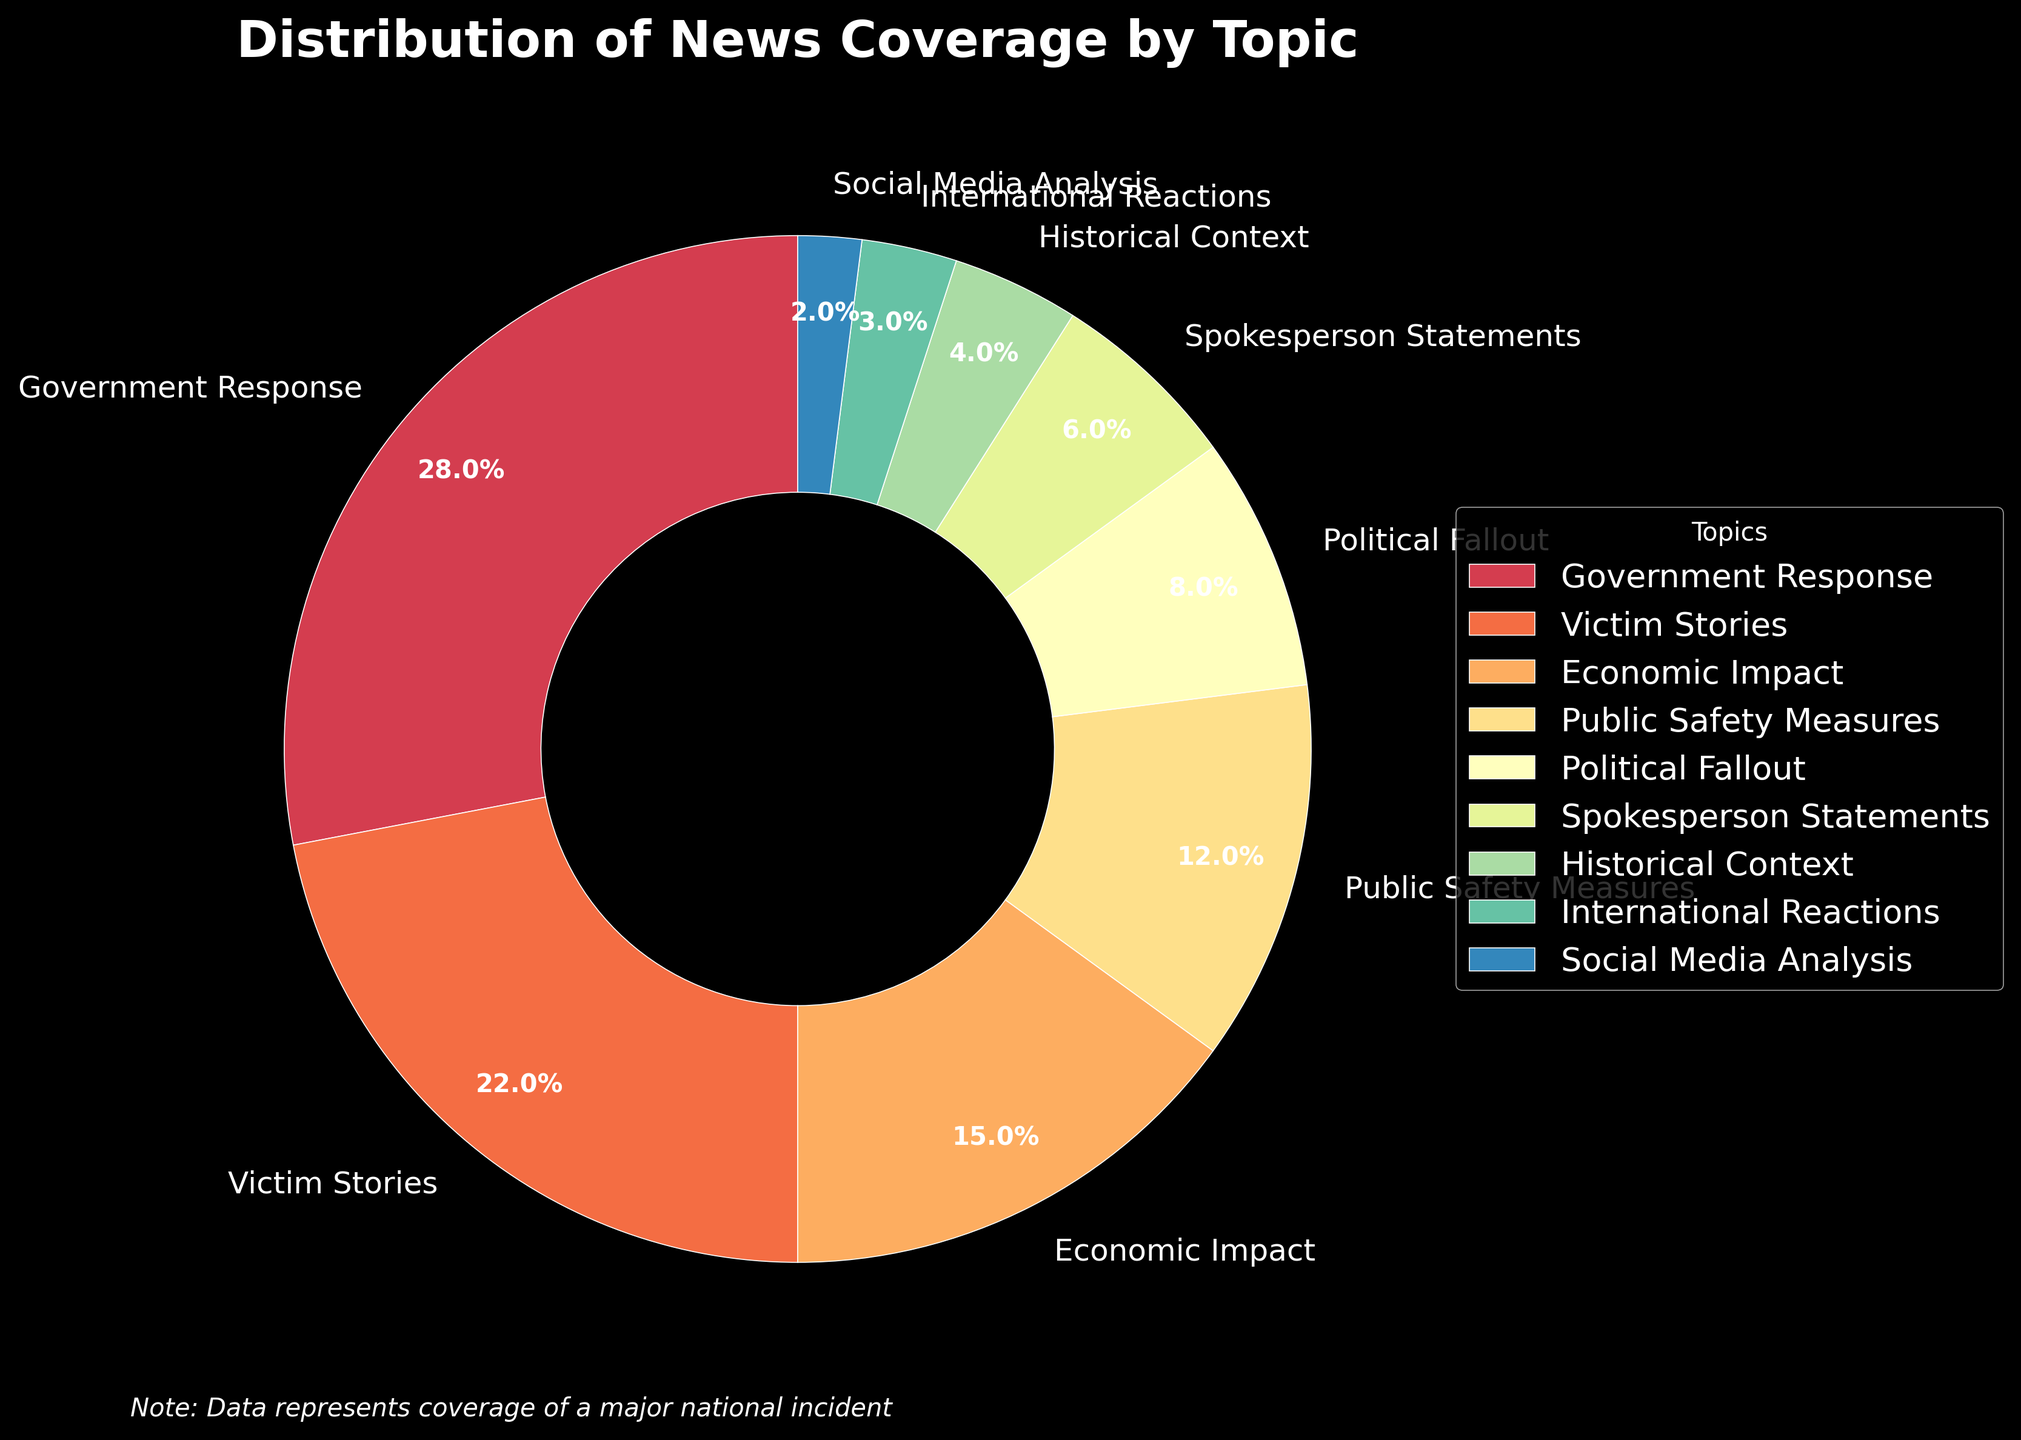What percentage of the news coverage is dedicated to the top two topics? The top two topics are "Government Response" and "Victim Stories," which have percentages of 28% and 22%, respectively. Adding these percentages together gives 28% + 22% = 50%.
Answer: 50% Which topic has the least news coverage? By examining the pie chart, the topic "Social Media Analysis" has the smallest slice, indicating the least coverage at 2%.
Answer: Social Media Analysis How does the coverage of "Economic Impact" compare to that of "Political Fallout"? The coverage of "Economic Impact" is 15%, while "Political Fallout" is 8%. To compare, subtract 8% from 15%, giving 15% - 8% = 7%. Thus, "Economic Impact" has 7% more coverage than "Political Fallout".
Answer: Economic Impact has 7% more coverage What is the combined coverage percentage of "Public Safety Measures" and "Spokesperson Statements"? "Public Safety Measures" has 12% coverage, and "Spokesperson Statements" has 6% coverage. Adding these together, we get 12% + 6% = 18%.
Answer: 18% Rank the topics in descending order based on their coverage percentage. The topics ranked in descending order based on the pie chart are:
1. Government Response (28%)
2. Victim Stories (22%)
3. Economic Impact (15%)
4. Public Safety Measures (12%)
5. Political Fallout (8%)
6. Spokesperson Statements (6%)
7. Historical Context (4%)
8. International Reactions (3%)
9. Social Media Analysis (2%)
Answer: Government Response, Victim Stories, Economic Impact, Public Safety Measures, Political Fallout, Spokesperson Statements, Historical Context, International Reactions, Social Media Analysis What proportion of the news coverage is related to reactions, including "Spokesperson Statements," "International Reactions," and "Social Media Analysis"? The percentages for "Spokesperson Statements," "International Reactions," and "Social Media Analysis" are 6%, 3%, and 2%, respectively. Adding these together, 6% + 3% + 2% = 11%. Thus, 11% of the news coverage is related to these reactions.
Answer: 11% Which topic's coverage is the median value among all topics listed, and what is that value? There are 9 topics in total. To find the median, we need the 5th value in the ascending list. The sorted percentages are: 2%, 3%, 4%, 6%, 8%, 12%, 15%, 22%, 28%. The 5th value is 8%, corresponding to "Political Fallout".
Answer: Political Fallout, 8% If the coverage of "Public Safety Measures" increased by 5%, how would that affect its rank in the list? If "Public Safety Measures" increased by 5%, its coverage would be 12% + 5% = 17%. This would make it rank 3rd after "Government Response" (28%) and "Victim Stories" (22%), pushing "Economic Impact" (15%) to the 4th rank.
Answer: 3rd By how much does the "Government Response" coverage exceed the average coverage percentage of all topics? To find the average percentage, sum all percentages: 28% + 22% + 15% + 12% + 8% + 6% + 4% + 3% + 2% = 100%. Dividing by 9 topics, the average is 100% / 9 ≈ 11.1%. "Government Response" is 28%, so the difference is 28% - 11.1% ≈ 16.9%.
Answer: 16.9% Identify the topics that cumulatively make up more than half of the total news coverage. Summing the largest percentages until exceeding 50%: "Government Response" (28%) + "Victim Stories" (22%) = 50%. The next topic, "Economic Impact," makes the sum exceed 50%. Therefore, "Government Response" and "Victim Stories" cumulatively make up exactly 50%.
Answer: Government Response and Victim Stories 